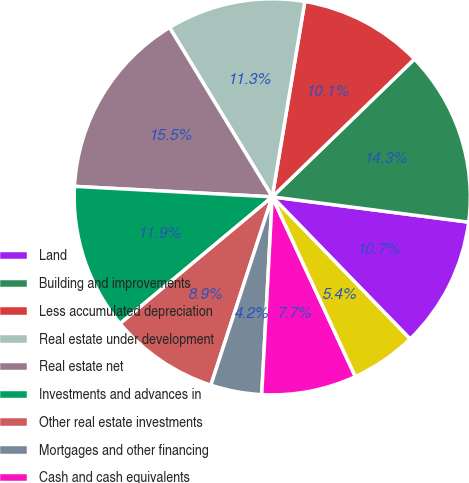Convert chart to OTSL. <chart><loc_0><loc_0><loc_500><loc_500><pie_chart><fcel>Land<fcel>Building and improvements<fcel>Less accumulated depreciation<fcel>Real estate under development<fcel>Real estate net<fcel>Investments and advances in<fcel>Other real estate investments<fcel>Mortgages and other financing<fcel>Cash and cash equivalents<fcel>Marketable securities<nl><fcel>10.71%<fcel>14.29%<fcel>10.12%<fcel>11.31%<fcel>15.48%<fcel>11.9%<fcel>8.93%<fcel>4.17%<fcel>7.74%<fcel>5.36%<nl></chart> 